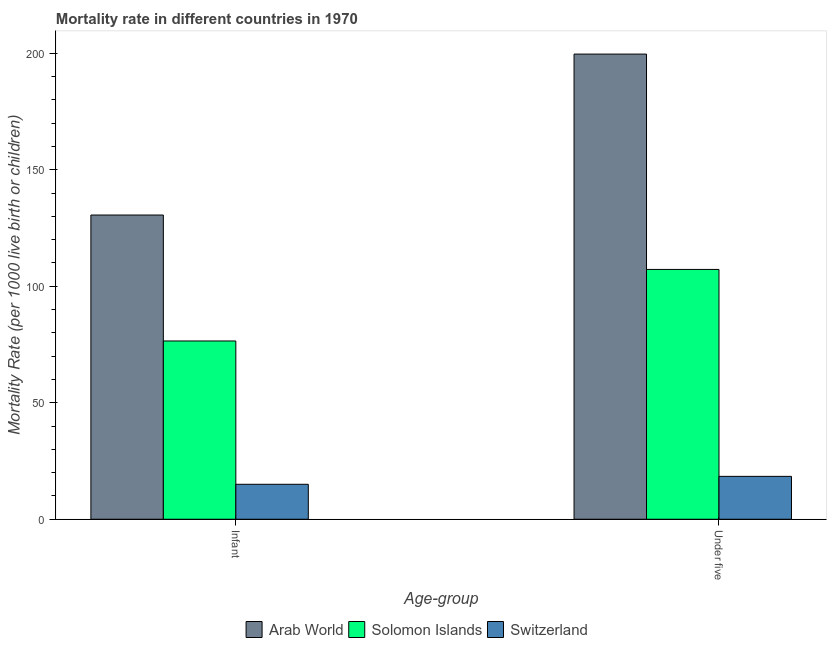Are the number of bars on each tick of the X-axis equal?
Your answer should be very brief. Yes. How many bars are there on the 1st tick from the right?
Offer a very short reply. 3. What is the label of the 2nd group of bars from the left?
Ensure brevity in your answer.  Under five. Across all countries, what is the maximum infant mortality rate?
Provide a short and direct response. 130.55. Across all countries, what is the minimum infant mortality rate?
Offer a very short reply. 15. In which country was the infant mortality rate maximum?
Give a very brief answer. Arab World. In which country was the infant mortality rate minimum?
Ensure brevity in your answer.  Switzerland. What is the total infant mortality rate in the graph?
Your answer should be very brief. 222.05. What is the difference between the under-5 mortality rate in Solomon Islands and that in Arab World?
Ensure brevity in your answer.  -92.42. What is the difference between the infant mortality rate in Solomon Islands and the under-5 mortality rate in Arab World?
Provide a short and direct response. -123.12. What is the average under-5 mortality rate per country?
Make the answer very short. 108.41. What is the difference between the infant mortality rate and under-5 mortality rate in Solomon Islands?
Your answer should be compact. -30.7. What is the ratio of the under-5 mortality rate in Solomon Islands to that in Arab World?
Ensure brevity in your answer.  0.54. Is the infant mortality rate in Switzerland less than that in Solomon Islands?
Your answer should be very brief. Yes. What does the 3rd bar from the left in Under five represents?
Your answer should be compact. Switzerland. What does the 3rd bar from the right in Under five represents?
Ensure brevity in your answer.  Arab World. Are all the bars in the graph horizontal?
Offer a terse response. No. Are the values on the major ticks of Y-axis written in scientific E-notation?
Give a very brief answer. No. Does the graph contain any zero values?
Provide a succinct answer. No. Does the graph contain grids?
Provide a succinct answer. No. Where does the legend appear in the graph?
Make the answer very short. Bottom center. How many legend labels are there?
Your answer should be very brief. 3. What is the title of the graph?
Give a very brief answer. Mortality rate in different countries in 1970. Does "Tuvalu" appear as one of the legend labels in the graph?
Offer a very short reply. No. What is the label or title of the X-axis?
Keep it short and to the point. Age-group. What is the label or title of the Y-axis?
Keep it short and to the point. Mortality Rate (per 1000 live birth or children). What is the Mortality Rate (per 1000 live birth or children) of Arab World in Infant?
Ensure brevity in your answer.  130.55. What is the Mortality Rate (per 1000 live birth or children) of Solomon Islands in Infant?
Provide a short and direct response. 76.5. What is the Mortality Rate (per 1000 live birth or children) of Arab World in Under five?
Give a very brief answer. 199.62. What is the Mortality Rate (per 1000 live birth or children) in Solomon Islands in Under five?
Keep it short and to the point. 107.2. What is the Mortality Rate (per 1000 live birth or children) in Switzerland in Under five?
Your answer should be very brief. 18.4. Across all Age-group, what is the maximum Mortality Rate (per 1000 live birth or children) of Arab World?
Give a very brief answer. 199.62. Across all Age-group, what is the maximum Mortality Rate (per 1000 live birth or children) of Solomon Islands?
Make the answer very short. 107.2. Across all Age-group, what is the maximum Mortality Rate (per 1000 live birth or children) in Switzerland?
Provide a succinct answer. 18.4. Across all Age-group, what is the minimum Mortality Rate (per 1000 live birth or children) of Arab World?
Your response must be concise. 130.55. Across all Age-group, what is the minimum Mortality Rate (per 1000 live birth or children) in Solomon Islands?
Your response must be concise. 76.5. What is the total Mortality Rate (per 1000 live birth or children) of Arab World in the graph?
Provide a succinct answer. 330.17. What is the total Mortality Rate (per 1000 live birth or children) of Solomon Islands in the graph?
Your answer should be compact. 183.7. What is the total Mortality Rate (per 1000 live birth or children) in Switzerland in the graph?
Provide a succinct answer. 33.4. What is the difference between the Mortality Rate (per 1000 live birth or children) of Arab World in Infant and that in Under five?
Your answer should be compact. -69.07. What is the difference between the Mortality Rate (per 1000 live birth or children) in Solomon Islands in Infant and that in Under five?
Your answer should be compact. -30.7. What is the difference between the Mortality Rate (per 1000 live birth or children) in Arab World in Infant and the Mortality Rate (per 1000 live birth or children) in Solomon Islands in Under five?
Ensure brevity in your answer.  23.35. What is the difference between the Mortality Rate (per 1000 live birth or children) in Arab World in Infant and the Mortality Rate (per 1000 live birth or children) in Switzerland in Under five?
Keep it short and to the point. 112.15. What is the difference between the Mortality Rate (per 1000 live birth or children) of Solomon Islands in Infant and the Mortality Rate (per 1000 live birth or children) of Switzerland in Under five?
Your response must be concise. 58.1. What is the average Mortality Rate (per 1000 live birth or children) of Arab World per Age-group?
Make the answer very short. 165.08. What is the average Mortality Rate (per 1000 live birth or children) in Solomon Islands per Age-group?
Provide a short and direct response. 91.85. What is the difference between the Mortality Rate (per 1000 live birth or children) in Arab World and Mortality Rate (per 1000 live birth or children) in Solomon Islands in Infant?
Give a very brief answer. 54.05. What is the difference between the Mortality Rate (per 1000 live birth or children) of Arab World and Mortality Rate (per 1000 live birth or children) of Switzerland in Infant?
Keep it short and to the point. 115.55. What is the difference between the Mortality Rate (per 1000 live birth or children) in Solomon Islands and Mortality Rate (per 1000 live birth or children) in Switzerland in Infant?
Your answer should be very brief. 61.5. What is the difference between the Mortality Rate (per 1000 live birth or children) of Arab World and Mortality Rate (per 1000 live birth or children) of Solomon Islands in Under five?
Offer a terse response. 92.42. What is the difference between the Mortality Rate (per 1000 live birth or children) of Arab World and Mortality Rate (per 1000 live birth or children) of Switzerland in Under five?
Provide a short and direct response. 181.22. What is the difference between the Mortality Rate (per 1000 live birth or children) of Solomon Islands and Mortality Rate (per 1000 live birth or children) of Switzerland in Under five?
Ensure brevity in your answer.  88.8. What is the ratio of the Mortality Rate (per 1000 live birth or children) in Arab World in Infant to that in Under five?
Offer a very short reply. 0.65. What is the ratio of the Mortality Rate (per 1000 live birth or children) of Solomon Islands in Infant to that in Under five?
Make the answer very short. 0.71. What is the ratio of the Mortality Rate (per 1000 live birth or children) in Switzerland in Infant to that in Under five?
Provide a short and direct response. 0.82. What is the difference between the highest and the second highest Mortality Rate (per 1000 live birth or children) in Arab World?
Provide a succinct answer. 69.07. What is the difference between the highest and the second highest Mortality Rate (per 1000 live birth or children) in Solomon Islands?
Your answer should be compact. 30.7. What is the difference between the highest and the second highest Mortality Rate (per 1000 live birth or children) of Switzerland?
Provide a succinct answer. 3.4. What is the difference between the highest and the lowest Mortality Rate (per 1000 live birth or children) in Arab World?
Your response must be concise. 69.07. What is the difference between the highest and the lowest Mortality Rate (per 1000 live birth or children) of Solomon Islands?
Your answer should be compact. 30.7. 